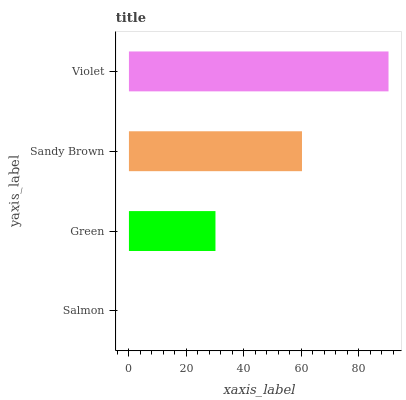Is Salmon the minimum?
Answer yes or no. Yes. Is Violet the maximum?
Answer yes or no. Yes. Is Green the minimum?
Answer yes or no. No. Is Green the maximum?
Answer yes or no. No. Is Green greater than Salmon?
Answer yes or no. Yes. Is Salmon less than Green?
Answer yes or no. Yes. Is Salmon greater than Green?
Answer yes or no. No. Is Green less than Salmon?
Answer yes or no. No. Is Sandy Brown the high median?
Answer yes or no. Yes. Is Green the low median?
Answer yes or no. Yes. Is Salmon the high median?
Answer yes or no. No. Is Sandy Brown the low median?
Answer yes or no. No. 